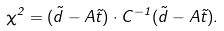<formula> <loc_0><loc_0><loc_500><loc_500>\chi ^ { 2 } = ( \vec { d } - A \vec { t } ) \cdot { C } ^ { - 1 } ( \vec { d } - A \vec { t } ) .</formula> 